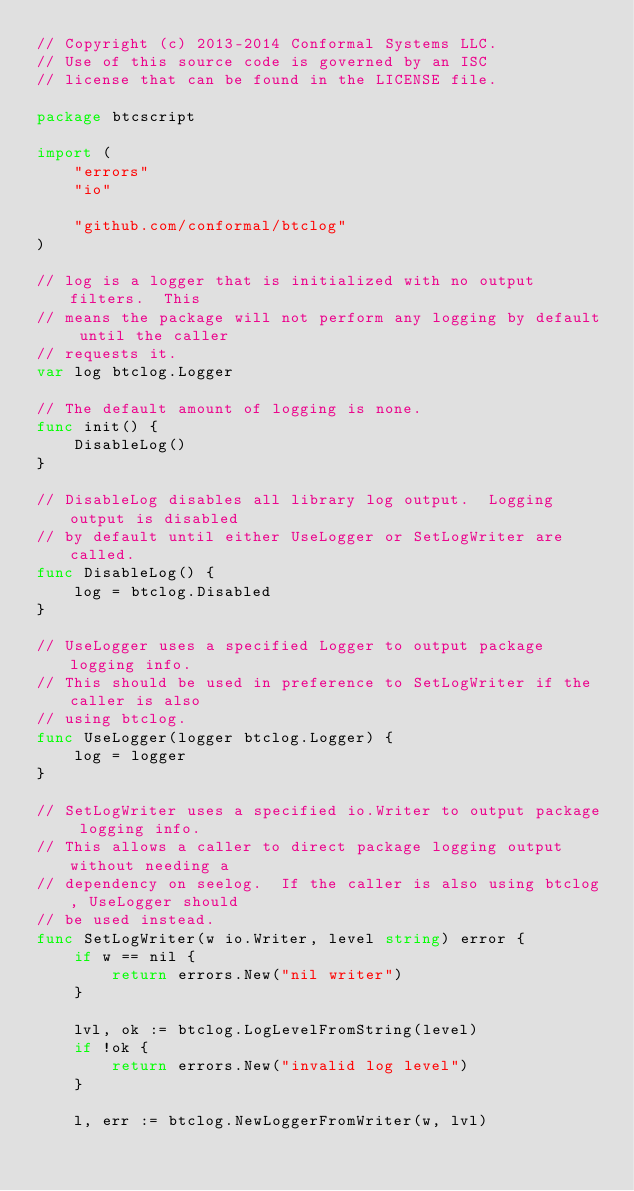<code> <loc_0><loc_0><loc_500><loc_500><_Go_>// Copyright (c) 2013-2014 Conformal Systems LLC.
// Use of this source code is governed by an ISC
// license that can be found in the LICENSE file.

package btcscript

import (
	"errors"
	"io"

	"github.com/conformal/btclog"
)

// log is a logger that is initialized with no output filters.  This
// means the package will not perform any logging by default until the caller
// requests it.
var log btclog.Logger

// The default amount of logging is none.
func init() {
	DisableLog()
}

// DisableLog disables all library log output.  Logging output is disabled
// by default until either UseLogger or SetLogWriter are called.
func DisableLog() {
	log = btclog.Disabled
}

// UseLogger uses a specified Logger to output package logging info.
// This should be used in preference to SetLogWriter if the caller is also
// using btclog.
func UseLogger(logger btclog.Logger) {
	log = logger
}

// SetLogWriter uses a specified io.Writer to output package logging info.
// This allows a caller to direct package logging output without needing a
// dependency on seelog.  If the caller is also using btclog, UseLogger should
// be used instead.
func SetLogWriter(w io.Writer, level string) error {
	if w == nil {
		return errors.New("nil writer")
	}

	lvl, ok := btclog.LogLevelFromString(level)
	if !ok {
		return errors.New("invalid log level")
	}

	l, err := btclog.NewLoggerFromWriter(w, lvl)</code> 